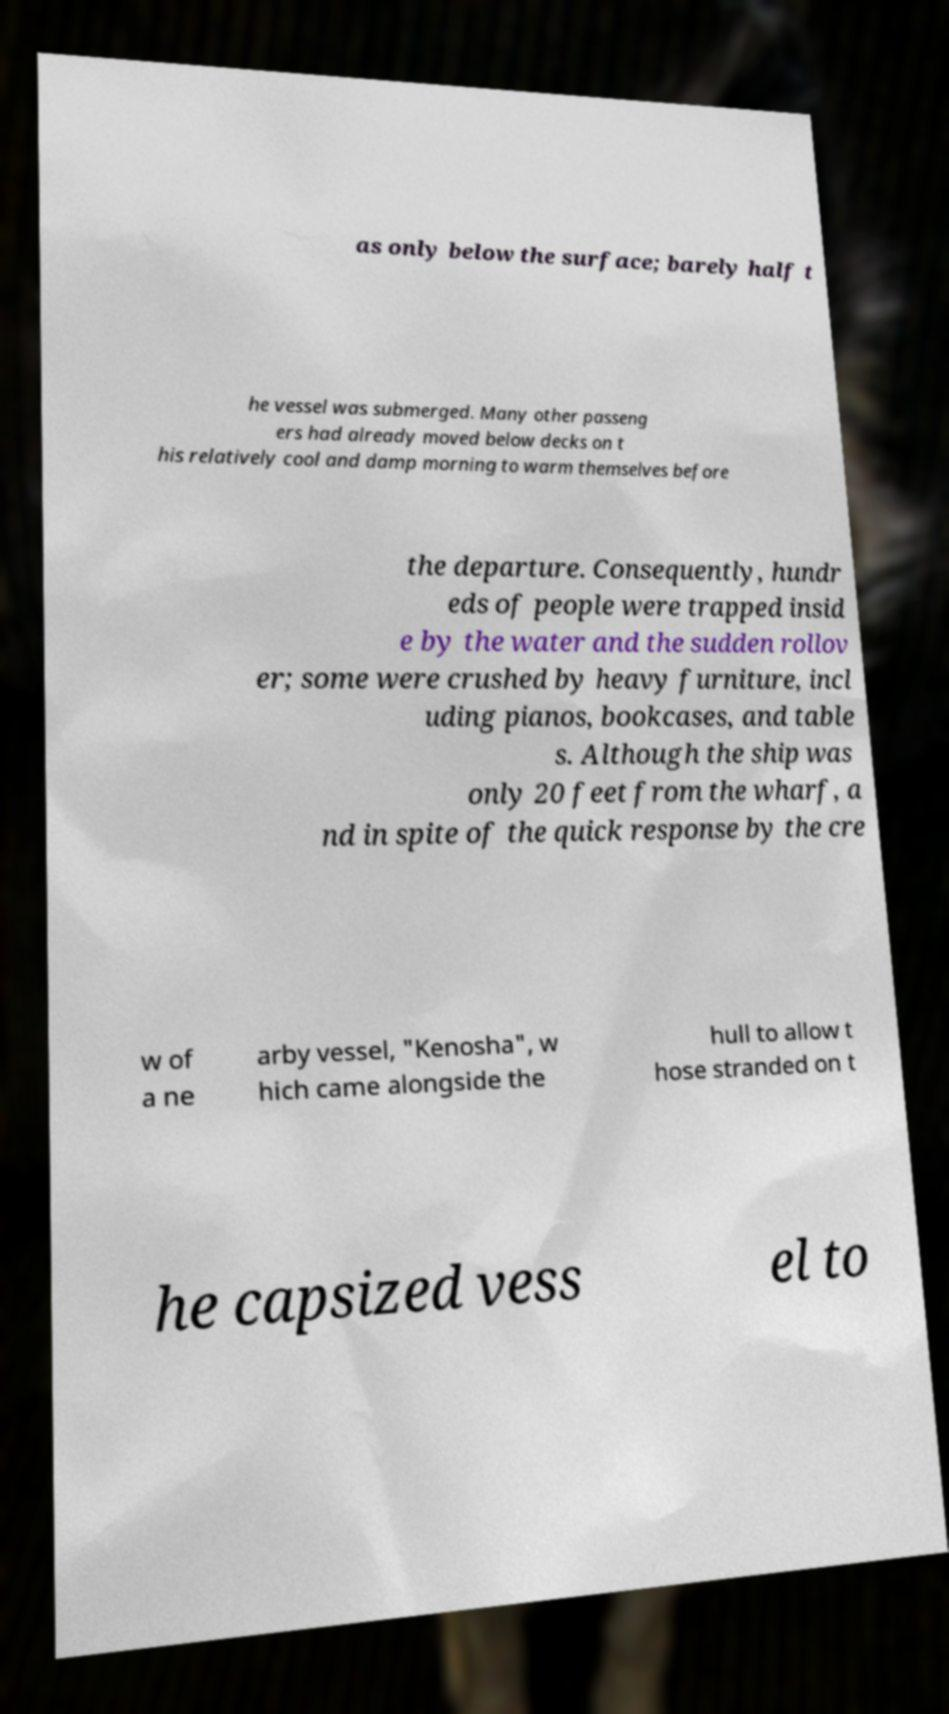Can you accurately transcribe the text from the provided image for me? as only below the surface; barely half t he vessel was submerged. Many other passeng ers had already moved below decks on t his relatively cool and damp morning to warm themselves before the departure. Consequently, hundr eds of people were trapped insid e by the water and the sudden rollov er; some were crushed by heavy furniture, incl uding pianos, bookcases, and table s. Although the ship was only 20 feet from the wharf, a nd in spite of the quick response by the cre w of a ne arby vessel, "Kenosha", w hich came alongside the hull to allow t hose stranded on t he capsized vess el to 